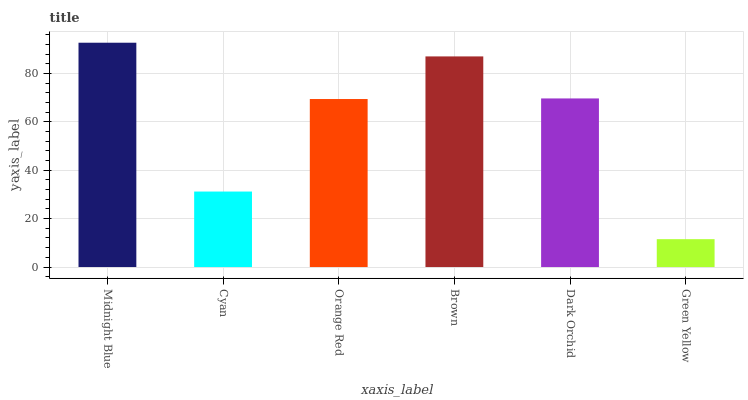Is Green Yellow the minimum?
Answer yes or no. Yes. Is Midnight Blue the maximum?
Answer yes or no. Yes. Is Cyan the minimum?
Answer yes or no. No. Is Cyan the maximum?
Answer yes or no. No. Is Midnight Blue greater than Cyan?
Answer yes or no. Yes. Is Cyan less than Midnight Blue?
Answer yes or no. Yes. Is Cyan greater than Midnight Blue?
Answer yes or no. No. Is Midnight Blue less than Cyan?
Answer yes or no. No. Is Dark Orchid the high median?
Answer yes or no. Yes. Is Orange Red the low median?
Answer yes or no. Yes. Is Cyan the high median?
Answer yes or no. No. Is Green Yellow the low median?
Answer yes or no. No. 